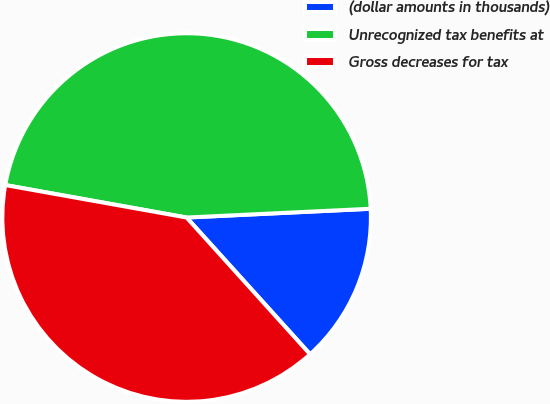Convert chart. <chart><loc_0><loc_0><loc_500><loc_500><pie_chart><fcel>(dollar amounts in thousands)<fcel>Unrecognized tax benefits at<fcel>Gross decreases for tax<nl><fcel>14.07%<fcel>46.42%<fcel>39.51%<nl></chart> 